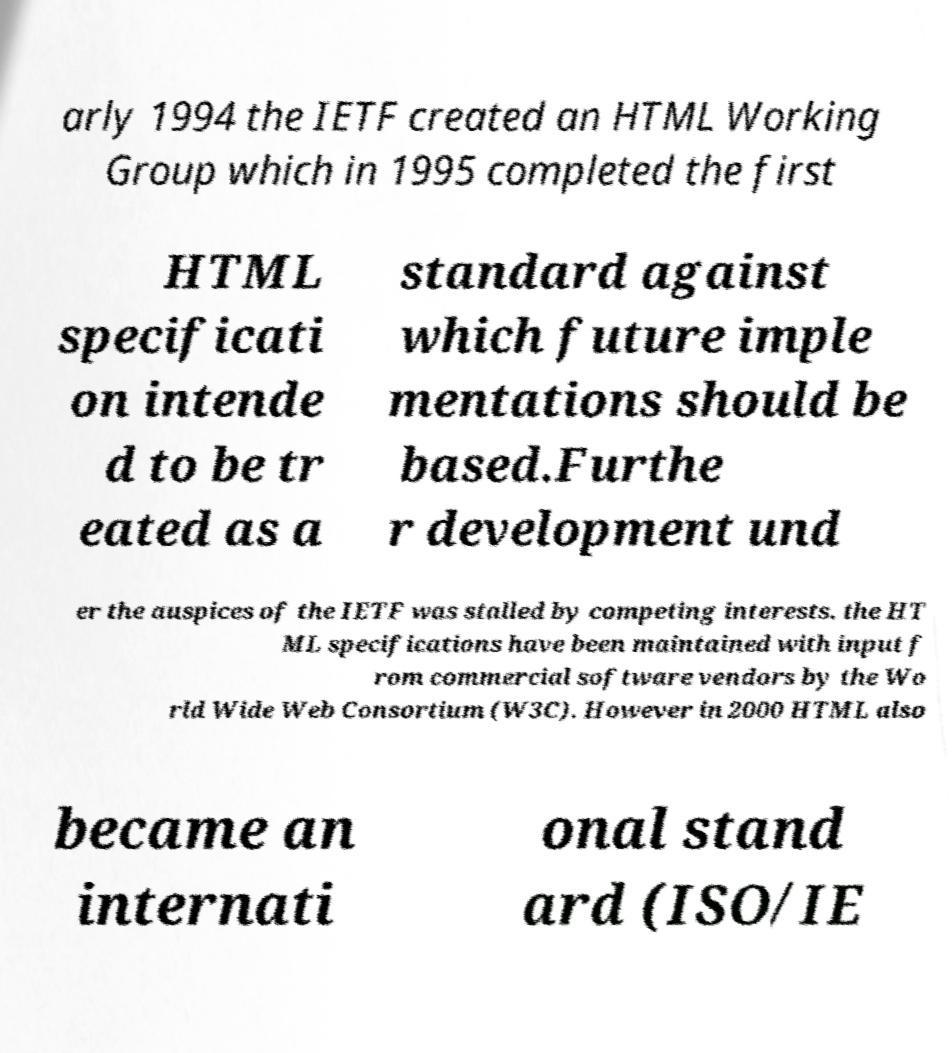There's text embedded in this image that I need extracted. Can you transcribe it verbatim? arly 1994 the IETF created an HTML Working Group which in 1995 completed the first HTML specificati on intende d to be tr eated as a standard against which future imple mentations should be based.Furthe r development und er the auspices of the IETF was stalled by competing interests. the HT ML specifications have been maintained with input f rom commercial software vendors by the Wo rld Wide Web Consortium (W3C). However in 2000 HTML also became an internati onal stand ard (ISO/IE 